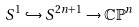<formula> <loc_0><loc_0><loc_500><loc_500>S ^ { 1 } \hookrightarrow S ^ { 2 n + 1 } \to \mathbb { C P } ^ { n }</formula> 